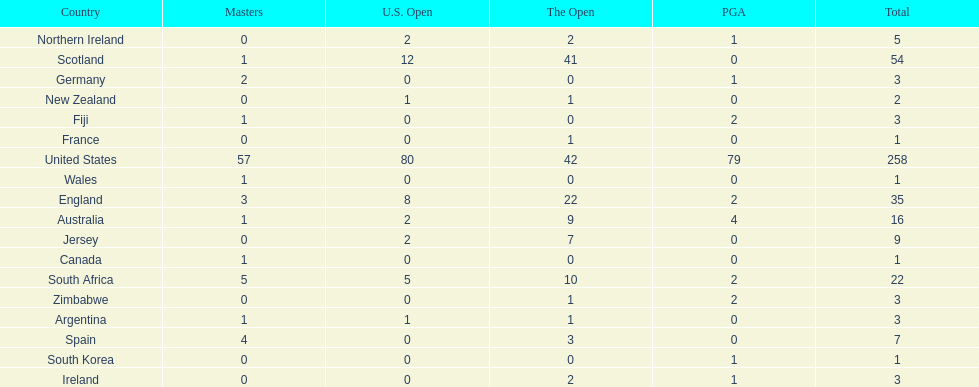How many total championships does spain have? 7. Parse the table in full. {'header': ['Country', 'Masters', 'U.S. Open', 'The Open', 'PGA', 'Total'], 'rows': [['Northern Ireland', '0', '2', '2', '1', '5'], ['Scotland', '1', '12', '41', '0', '54'], ['Germany', '2', '0', '0', '1', '3'], ['New Zealand', '0', '1', '1', '0', '2'], ['Fiji', '1', '0', '0', '2', '3'], ['France', '0', '0', '1', '0', '1'], ['United States', '57', '80', '42', '79', '258'], ['Wales', '1', '0', '0', '0', '1'], ['England', '3', '8', '22', '2', '35'], ['Australia', '1', '2', '9', '4', '16'], ['Jersey', '0', '2', '7', '0', '9'], ['Canada', '1', '0', '0', '0', '1'], ['South Africa', '5', '5', '10', '2', '22'], ['Zimbabwe', '0', '0', '1', '2', '3'], ['Argentina', '1', '1', '1', '0', '3'], ['Spain', '4', '0', '3', '0', '7'], ['South Korea', '0', '0', '0', '1', '1'], ['Ireland', '0', '0', '2', '1', '3']]} 